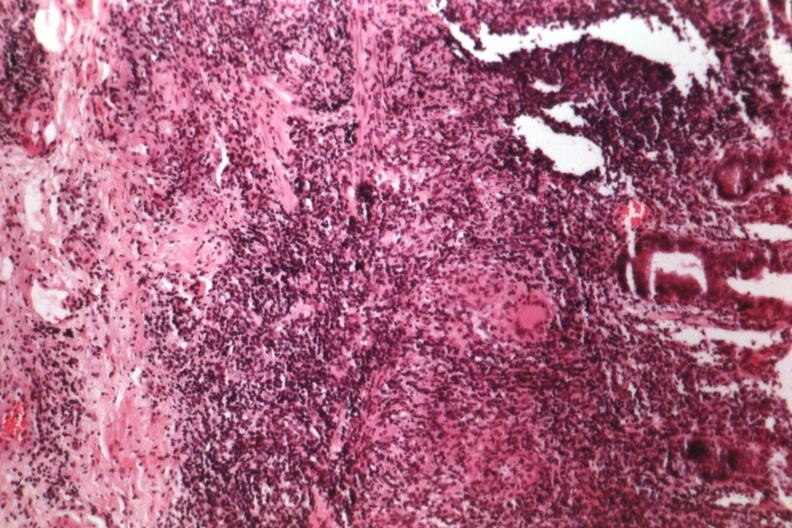does hemorrhage associated with placental abruption show source of granulomatous colitis?
Answer the question using a single word or phrase. No 